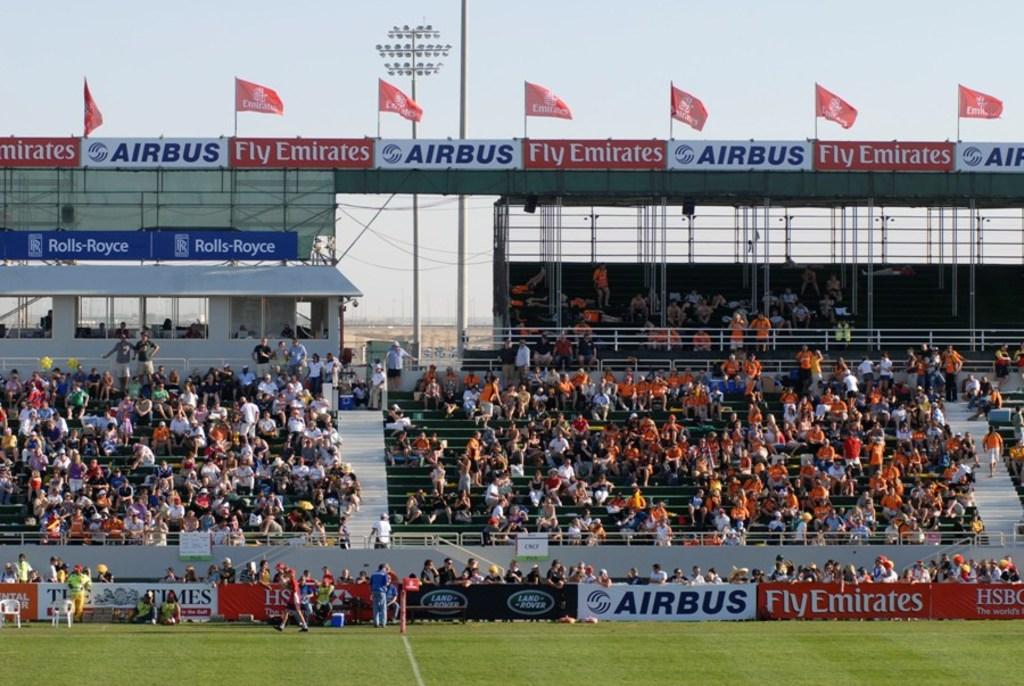What car brand is the sponsor?
Ensure brevity in your answer.  Airbus. What airlines are sponsors?
Provide a succinct answer. Airbus. 